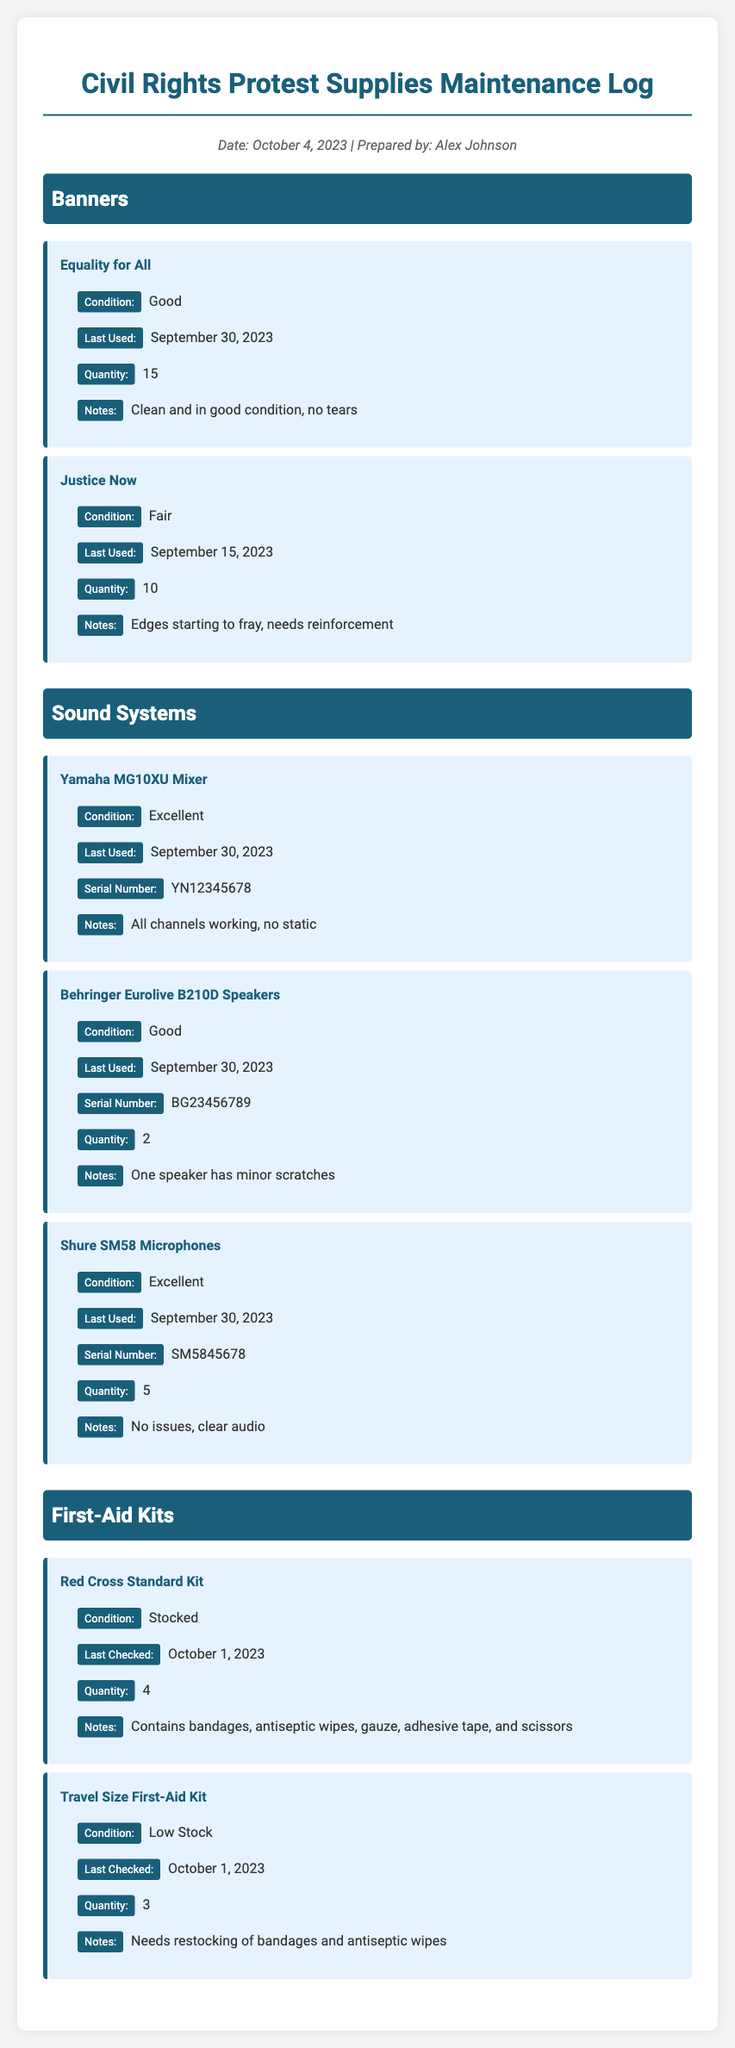What is the condition of the "Equality for All" banner? The condition of this banner is specifically stated in the document as "Good."
Answer: Good How many "Justice Now" banners are available? The quantity of "Justice Now" banners is mentioned as 10.
Answer: 10 What is the condition of the "Red Cross Standard Kit"? The document states that this first-aid kit is "Stocked."
Answer: Stocked When was the "Travel Size First-Aid Kit" last checked? This first-aid kit was last checked on October 1, 2023, according to the log.
Answer: October 1, 2023 How many microphones are listed in the maintenance log? The number of Shure SM58 Microphones listed is 5.
Answer: 5 What is the quantity of the "Behringer Eurolive B210D Speakers"? The document provides the quantity of these speakers as 2.
Answer: 2 Which item needs restocking of bandages and antiseptic wipes? The "Travel Size First-Aid Kit" needs restocking of these items, as noted in the details.
Answer: Travel Size First-Aid Kit What is the last used date for the "Yamaha MG10XU Mixer"? The last used date for this mixer is September 30, 2023, which is specified in the document.
Answer: September 30, 2023 